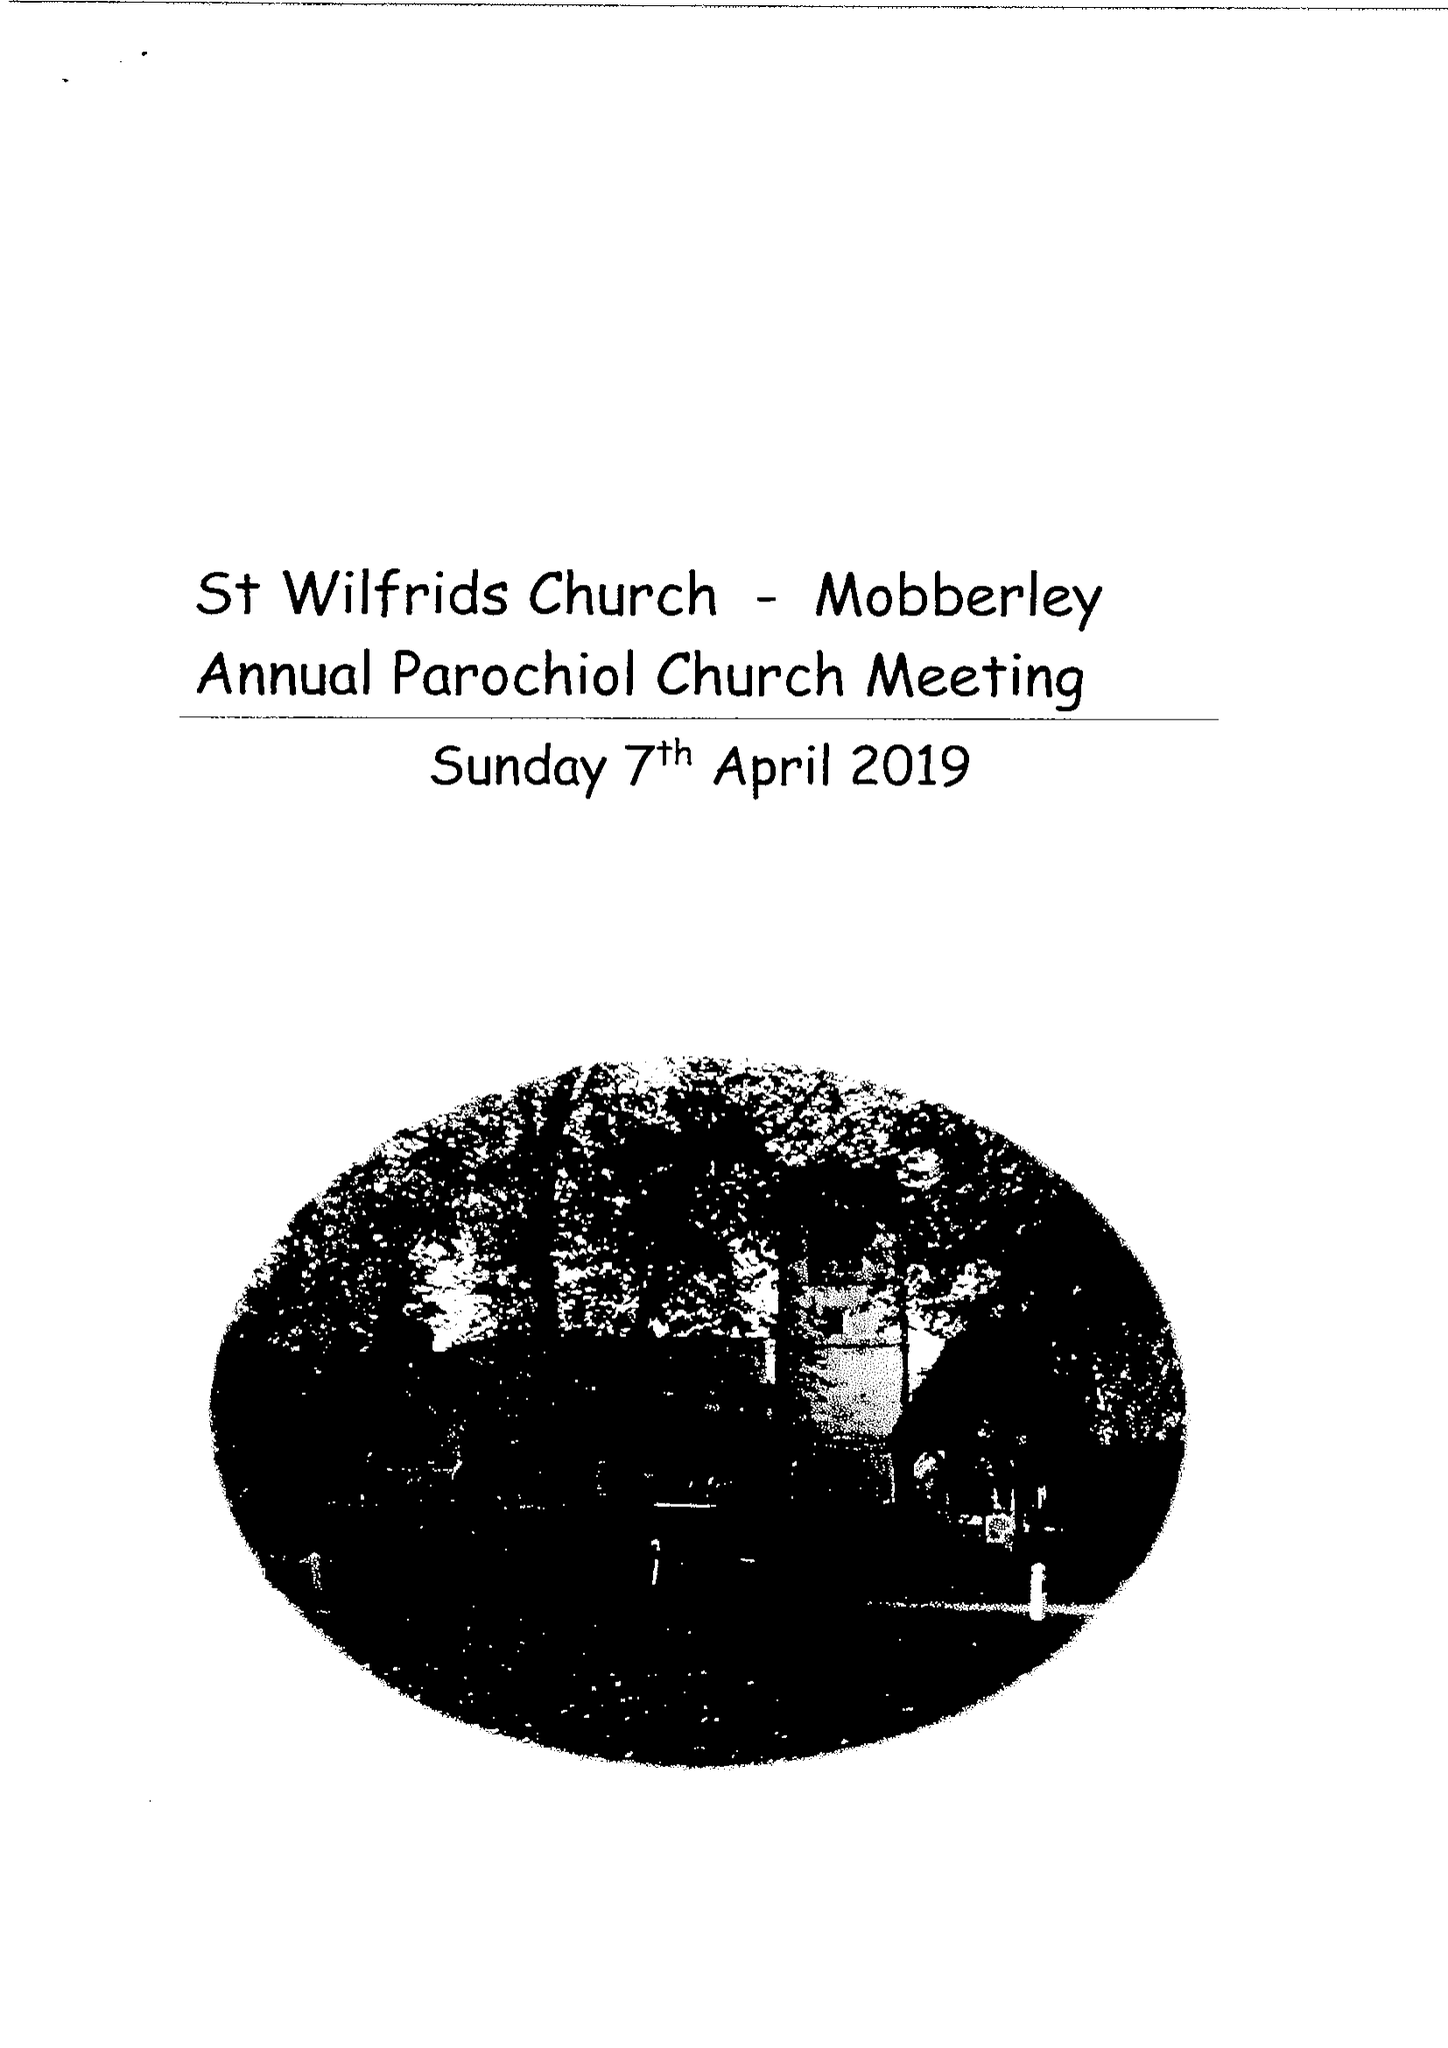What is the value for the charity_name?
Answer the question using a single word or phrase. The Parochial Church Council Of The Ecclesiastical Parish Of St. Wilfrid, Mobberley 